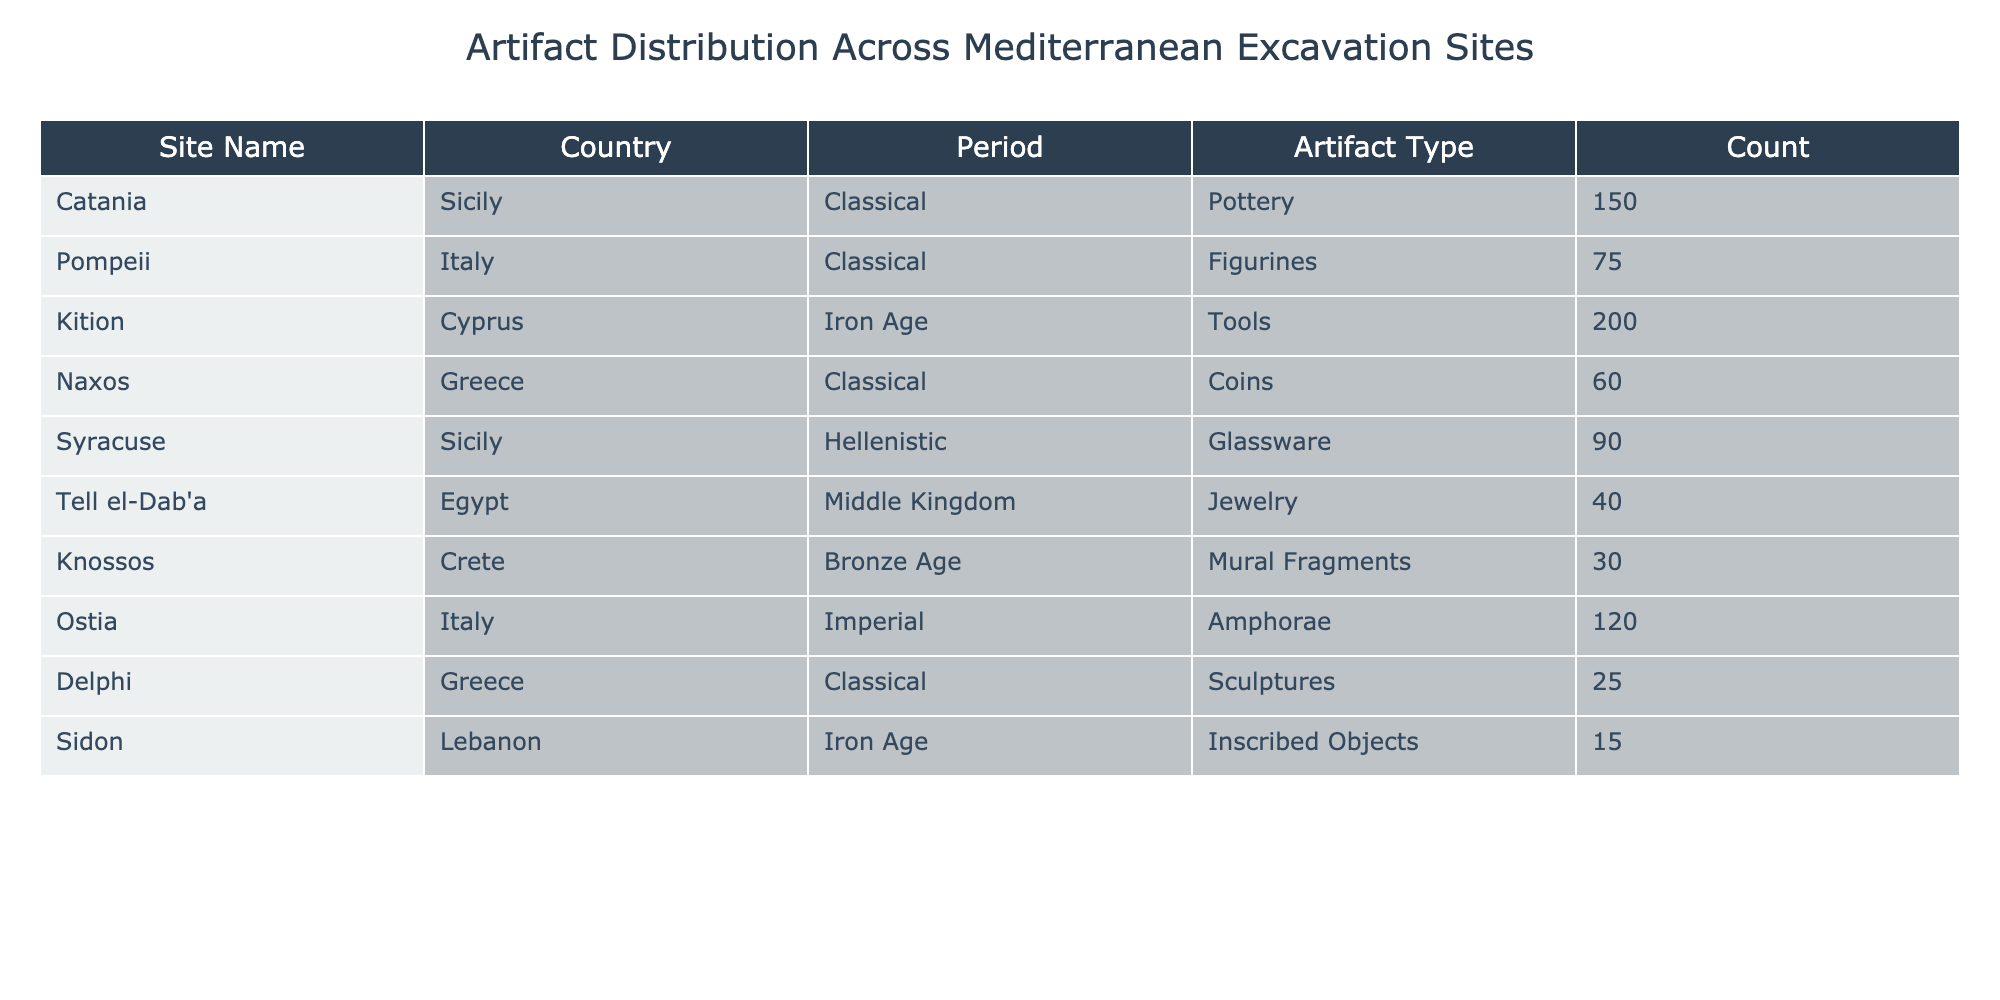What is the total count of artifacts found in Kition? The count of artifacts found in Kition is directly listed in the table as 200.
Answer: 200 How many different artifact types are listed for sites in Greece? The unique artifact types for Greece in the table are: Coins, Sculptures, which gives us a total of 2 different artifact types.
Answer: 2 Which excavation site has the highest count of artifacts, and what is that count? The highest count of artifacts is 200 found at Kition, which can be seen in the "Count" column of the table.
Answer: Kition, 200 Is there any artifact type that has more than 100 examples in the Mediterranean region? Yes, both Pottery (150 count) and Tools (200 count) have counts greater than 100. This can be verified by comparing the counts of artifacts in the table.
Answer: Yes What is the average count of artifacts across all sites listed? The total count of artifacts is (150 + 75 + 200 + 60 + 90 + 40 + 30 + 120 + 25 + 15) = 795, and there are 10 sites, so the average count is 795/10 = 79.5.
Answer: 79.5 How many artifact counts are associated with Hellenistic period sites? The only Hellenistic site listed is Syracuse, which has 90 artifacts associated with this period, as seen in the corresponding row of the table.
Answer: 90 Can you determine if any artifact types have counts that are equal or below 30? Yes, the Mural Fragments from Knossos have a count of 30, which can be verified in the table. This is the only artifact type that meets this criterion.
Answer: Yes What is the total number of artifacts found in Classical period sites? The Classical period sites are Catania (150), Pompeii (75), Naxos (60), and Delphi (25). Summing these gives (150 + 75 + 60 + 25) = 310.
Answer: 310 Which country has the least number of artifacts listed in this table, and what is that count? Lebanon has the least with Sidon's count of inscribed objects being 15, as seen in the table.
Answer: Lebanon, 15 